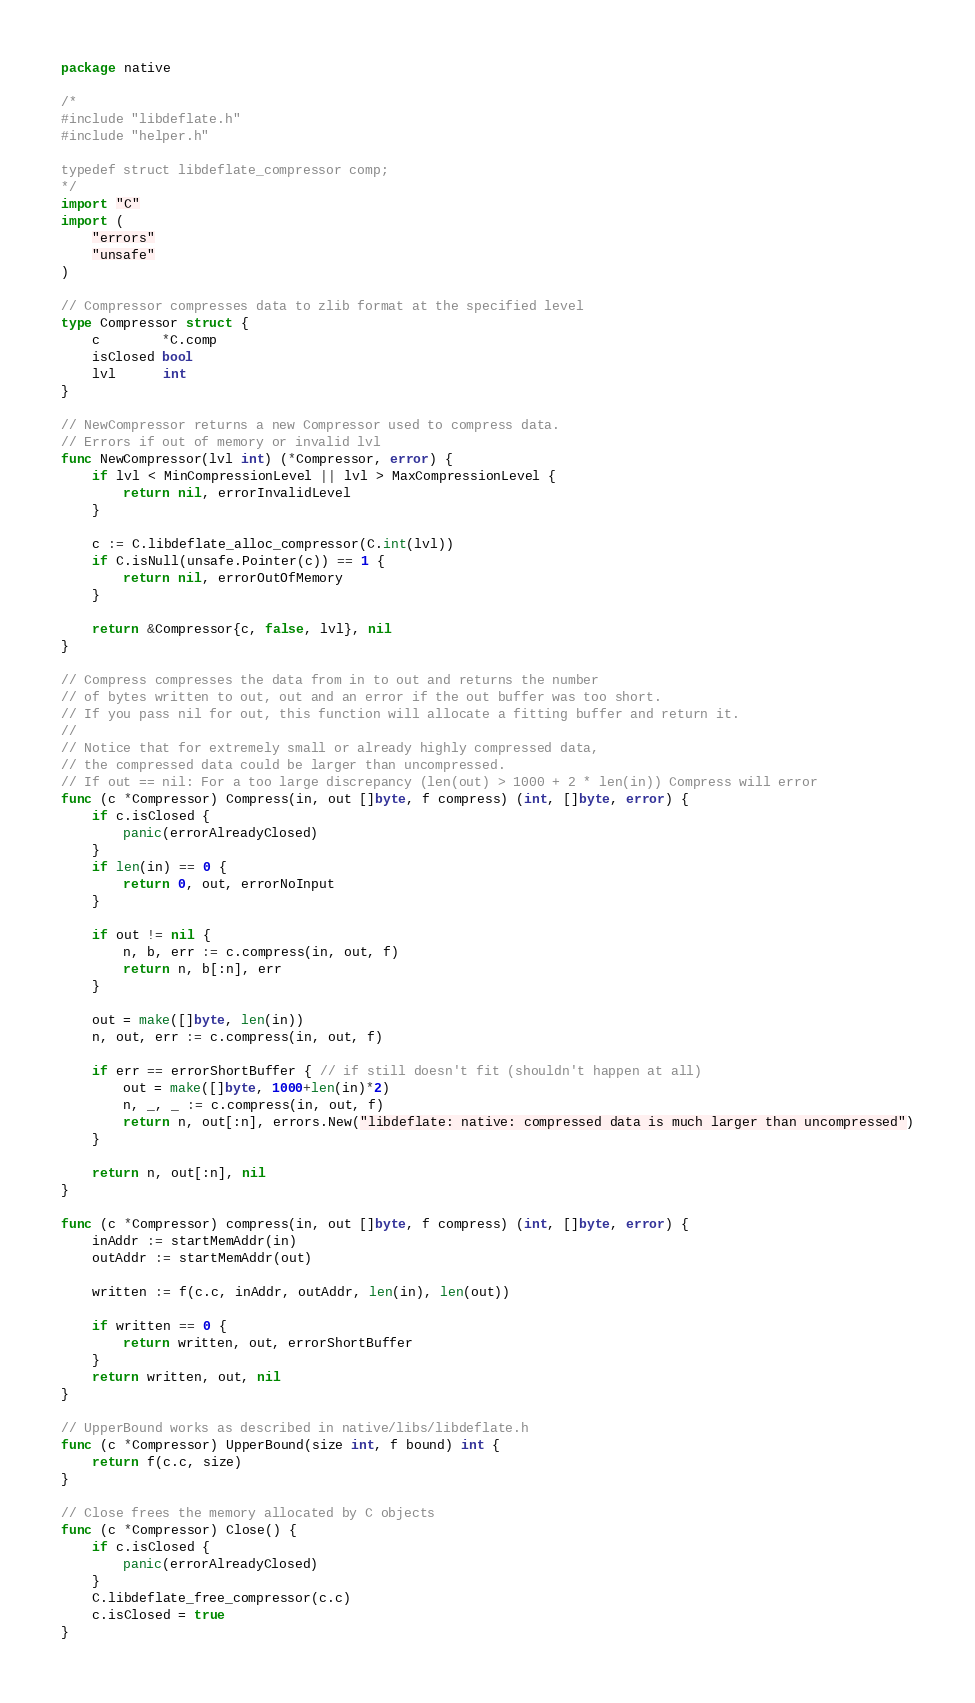<code> <loc_0><loc_0><loc_500><loc_500><_Go_>package native

/*
#include "libdeflate.h"
#include "helper.h"

typedef struct libdeflate_compressor comp;
*/
import "C"
import (
	"errors"
	"unsafe"
)

// Compressor compresses data to zlib format at the specified level
type Compressor struct {
	c        *C.comp
	isClosed bool
	lvl      int
}

// NewCompressor returns a new Compressor used to compress data.
// Errors if out of memory or invalid lvl
func NewCompressor(lvl int) (*Compressor, error) {
	if lvl < MinCompressionLevel || lvl > MaxCompressionLevel {
		return nil, errorInvalidLevel
	}

	c := C.libdeflate_alloc_compressor(C.int(lvl))
	if C.isNull(unsafe.Pointer(c)) == 1 {
		return nil, errorOutOfMemory
	}

	return &Compressor{c, false, lvl}, nil
}

// Compress compresses the data from in to out and returns the number
// of bytes written to out, out and an error if the out buffer was too short.
// If you pass nil for out, this function will allocate a fitting buffer and return it.
//
// Notice that for extremely small or already highly compressed data,
// the compressed data could be larger than uncompressed.
// If out == nil: For a too large discrepancy (len(out) > 1000 + 2 * len(in)) Compress will error
func (c *Compressor) Compress(in, out []byte, f compress) (int, []byte, error) {
	if c.isClosed {
		panic(errorAlreadyClosed)
	}
	if len(in) == 0 {
		return 0, out, errorNoInput
	}

	if out != nil {
		n, b, err := c.compress(in, out, f)
		return n, b[:n], err
	}

	out = make([]byte, len(in))
	n, out, err := c.compress(in, out, f)

	if err == errorShortBuffer { // if still doesn't fit (shouldn't happen at all)
		out = make([]byte, 1000+len(in)*2)
		n, _, _ := c.compress(in, out, f)
		return n, out[:n], errors.New("libdeflate: native: compressed data is much larger than uncompressed")
	}

	return n, out[:n], nil
}

func (c *Compressor) compress(in, out []byte, f compress) (int, []byte, error) {
	inAddr := startMemAddr(in)
	outAddr := startMemAddr(out)

	written := f(c.c, inAddr, outAddr, len(in), len(out))

	if written == 0 {
		return written, out, errorShortBuffer
	}
	return written, out, nil
}

// UpperBound works as described in native/libs/libdeflate.h
func (c *Compressor) UpperBound(size int, f bound) int {
	return f(c.c, size)
}

// Close frees the memory allocated by C objects
func (c *Compressor) Close() {
	if c.isClosed {
		panic(errorAlreadyClosed)
	}
	C.libdeflate_free_compressor(c.c)
	c.isClosed = true
}
</code> 